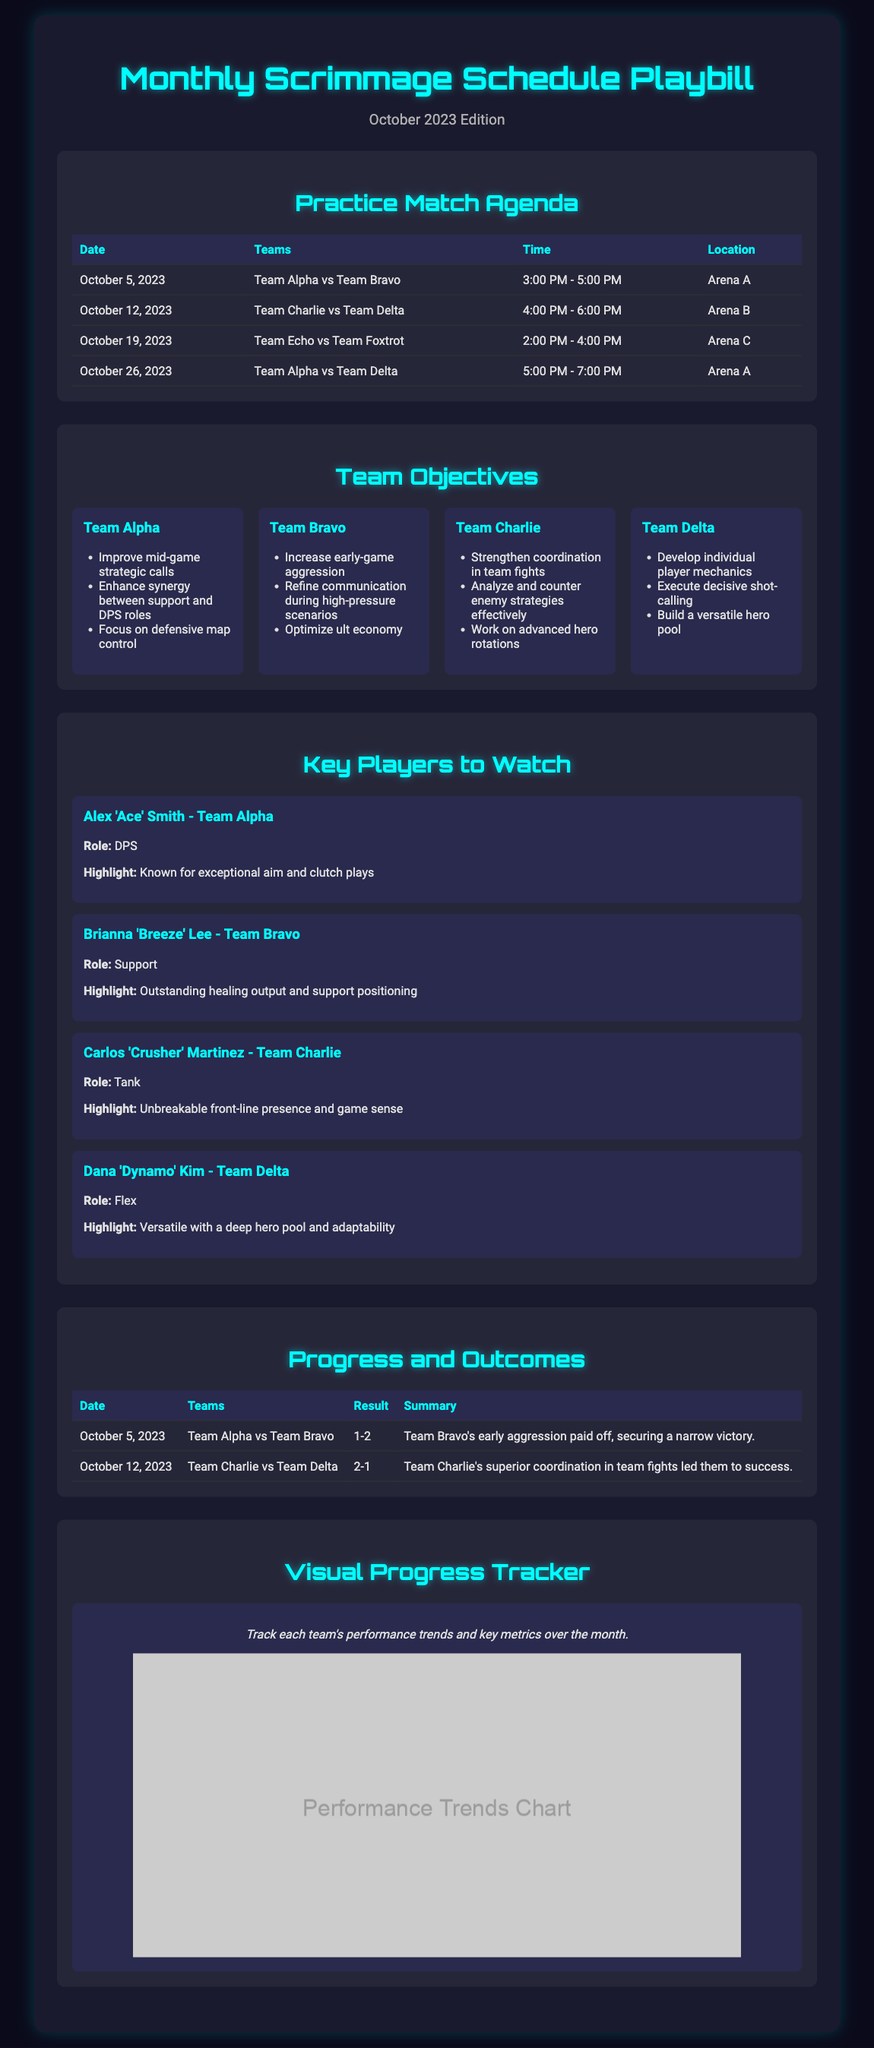What is the date of the first practice match? The first practice match is on October 5, 2023, as noted in the Practice Match Agenda section.
Answer: October 5, 2023 Which teams are playing on October 12, 2023? The teams playing on that date are Team Charlie and Team Delta, as detailed in the Practice Match Agenda section.
Answer: Team Charlie vs Team Delta What was the result of the match between Team Alpha and Team Bravo? The result is found in the Progress and Outcomes section, where it states Team Alpha lost to Team Bravo.
Answer: 1-2 Which player is known for exceptional aim and clutch plays? This information is provided in the Key Players to Watch section, specifically regarding Alex 'Ace' Smith from Team Alpha.
Answer: Alex 'Ace' Smith What objective does Team Bravo focus on during high-pressure scenarios? The team objectives for Team Bravo include refining communication during high-pressure scenarios, as mentioned in the Team Objectives section.
Answer: Refine communication What is the location for the match on October 26, 2023? The location is specified in the Practice Match Agenda section for that date, where it mentions Arena A.
Answer: Arena A What percentage of matches did Team Charlie win based on the provided results? Team Charlie won 2 out of 2 matches listed, indicating a 100% win rate in the provided outcomes.
Answer: 100% What do the colorful graphics in the document represent? The colorful graphics are designed to track each team's performance trends and key metrics over the month, as noted in the Visual Progress Tracker section.
Answer: Performance trends Which team aims to improve their mid-game strategic calls? Team Alpha is mentioned as focusing on improving mid-game strategic calls in the Team Objectives section.
Answer: Team Alpha 